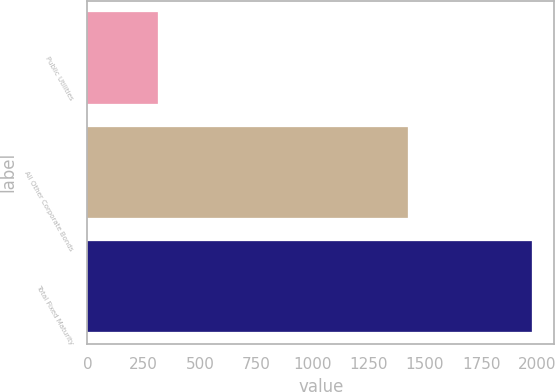Convert chart to OTSL. <chart><loc_0><loc_0><loc_500><loc_500><bar_chart><fcel>Public Utilities<fcel>All Other Corporate Bonds<fcel>Total Fixed Maturity<nl><fcel>315<fcel>1425.3<fcel>1974.6<nl></chart> 